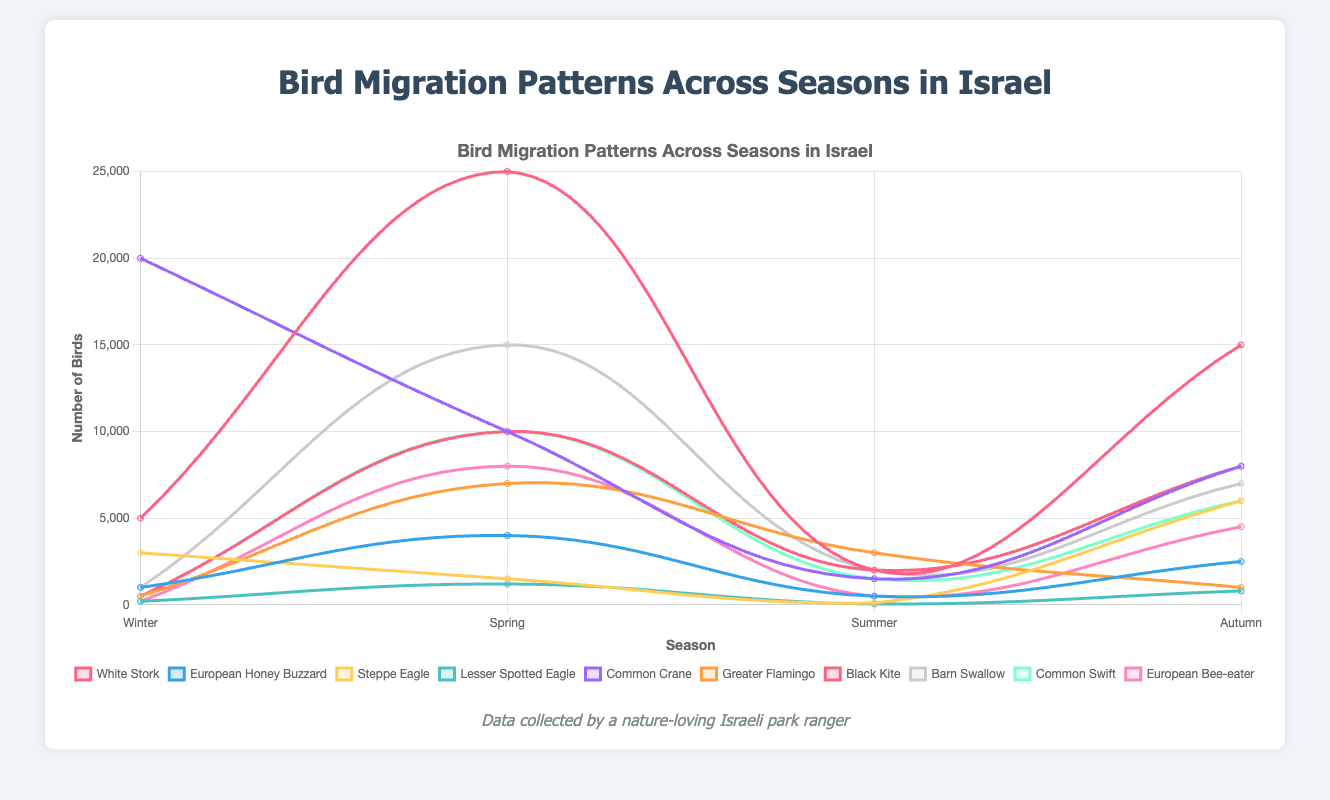What is the population trend of the White Stork throughout the seasons? The White Stork's population starts at 5000 in Winter, peaks at 25000 in Spring, drops to 2000 in Summer, and increases to 15000 in Autumn.
Answer: Peaks in Spring Which species has the highest number of birds in Winter? Looking at the Winter data points across species, the Common Crane has the highest number of birds with 20000.
Answer: Common Crane Compare the number of birds for the Black Kite and Barn Swallow in Spring. Which species has more? In Spring, the Black Kite has 10000 birds, while the Barn Swallow has 15000 birds. Therefore, the Barn Swallow has more birds in Spring.
Answer: Barn Swallow What is the total number of Lesser Spotted Eagles across all seasons? Add the numbers for Lesser Spotted Eagles in all seasons: 200 (Winter) + 1200 (Spring) + 50 (Summer) + 800 (Autumn) = 2250.
Answer: 2250 Which species has the lowest number of birds in Summer? Glancing at the Summer data, the Lesser Spotted Eagle has the lowest number of birds with just 50.
Answer: Lesser Spotted Eagle Is the number of Common Cranes in Winter higher than the number of European Honey Buzzards in Spring? Common Crane in Winter has 20000 birds, while European Honey Buzzard in Spring has 4000. Therefore, the Common Crane in Winter is higher.
Answer: Yes Which species shows the most balanced distribution across all seasons? To determine the most balanced distribution, compare the fluctuating numbers across seasons. The Steppe Eagle has more balanced numbers: 3000 (Winter), 1500 (Spring), 100 (Summer), and 6000 (Autumn). The numbers are relatively closer compared to other species.
Answer: Steppe Eagle 